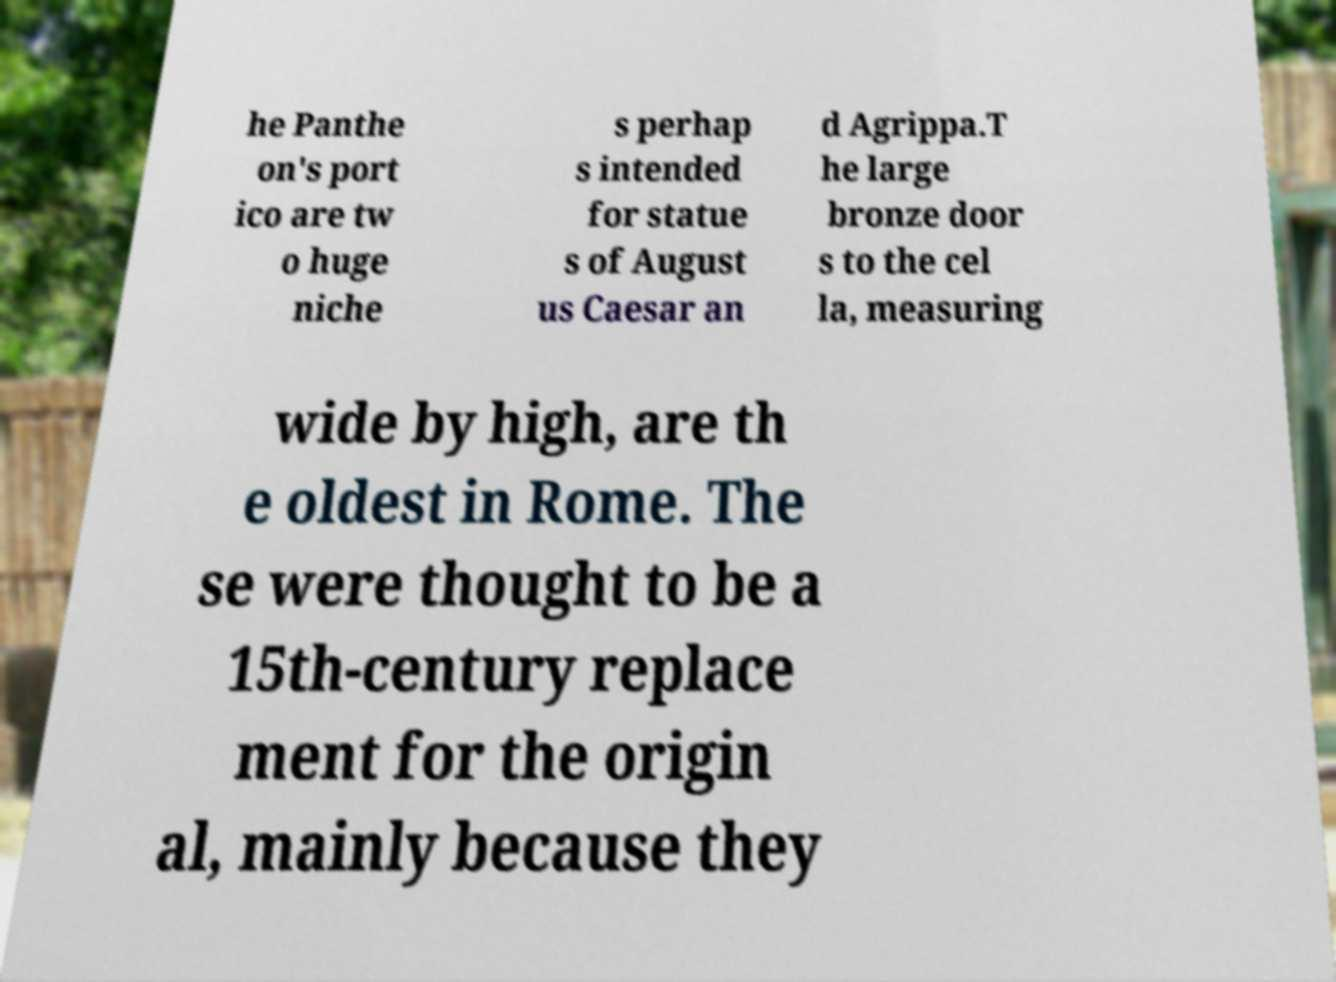Can you accurately transcribe the text from the provided image for me? he Panthe on's port ico are tw o huge niche s perhap s intended for statue s of August us Caesar an d Agrippa.T he large bronze door s to the cel la, measuring wide by high, are th e oldest in Rome. The se were thought to be a 15th-century replace ment for the origin al, mainly because they 